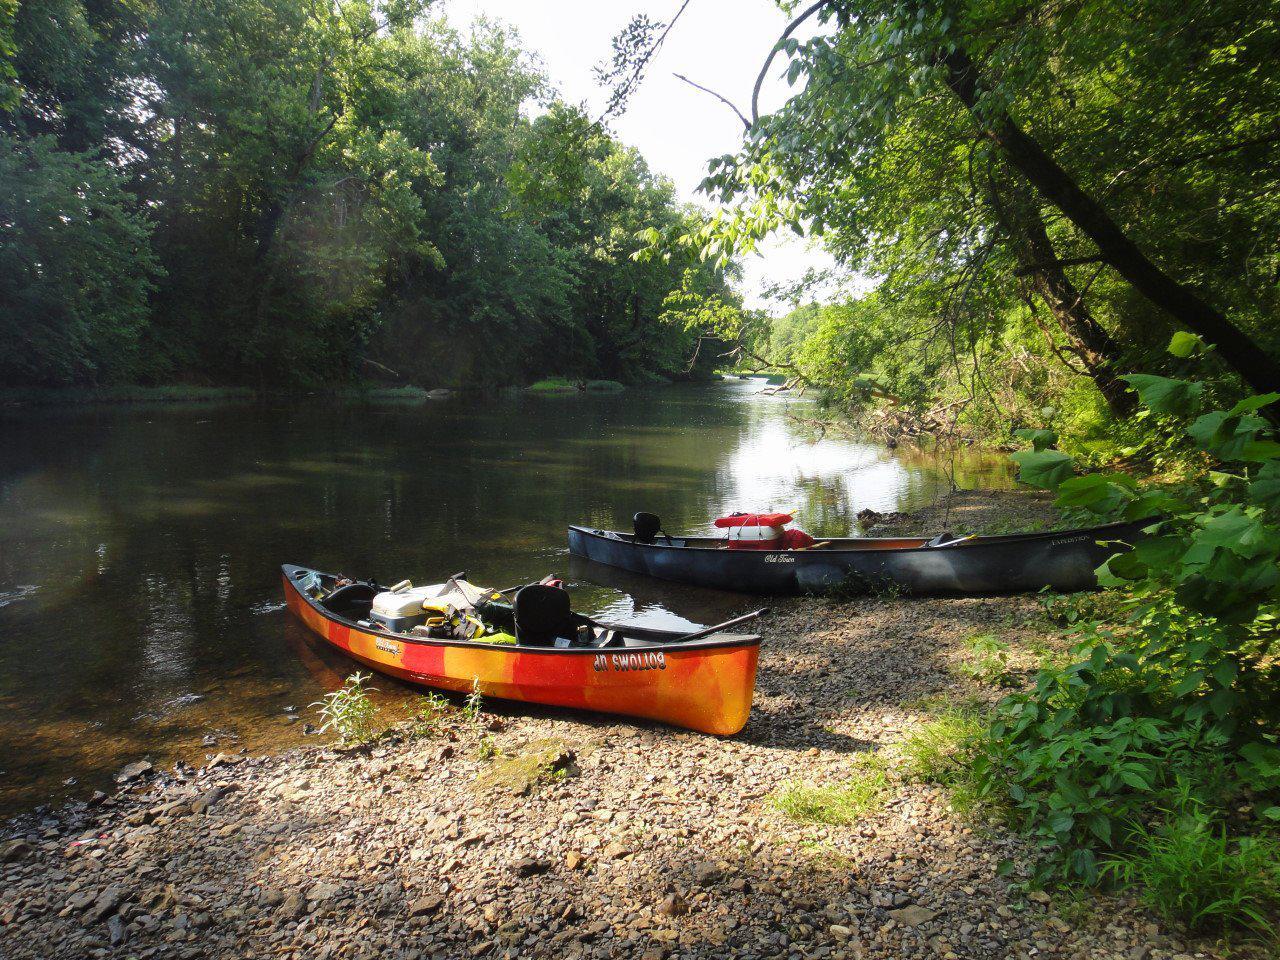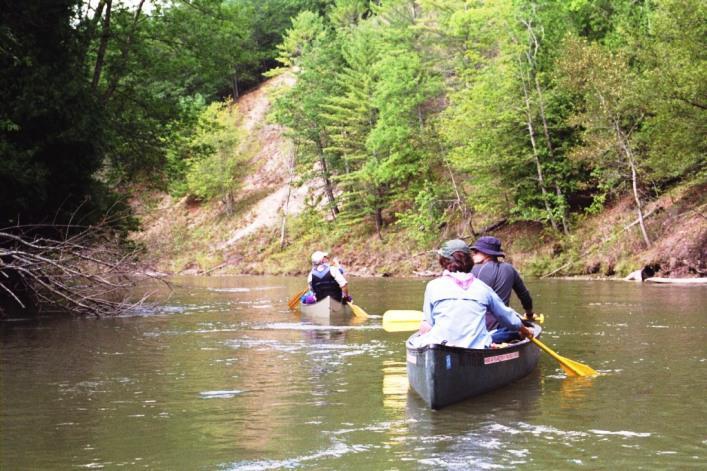The first image is the image on the left, the second image is the image on the right. Analyze the images presented: Is the assertion "Two canoes are upside down." valid? Answer yes or no. No. The first image is the image on the left, the second image is the image on the right. Analyze the images presented: Is the assertion "At least one boat has at least one person sitting in it." valid? Answer yes or no. Yes. 